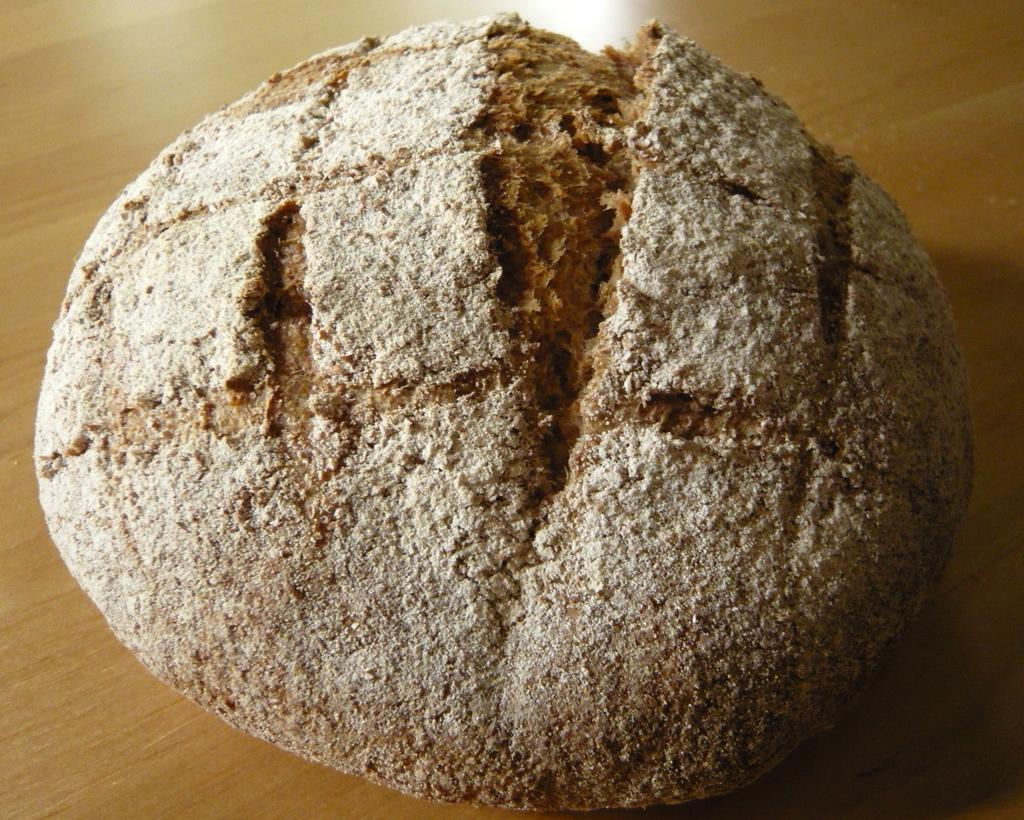What is the main subject of the image? The main subject of the image is dough. Where is the dough located in the image? The dough is placed on a wooden surface. What type of instrument is being played with the dough in the image? There is no instrument being played with the dough in the image; it is simply placed on a wooden surface. What degree of difficulty is associated with the dough in the image? There is no degree of difficulty associated with the dough in the image; it is just dough placed on a wooden surface. 